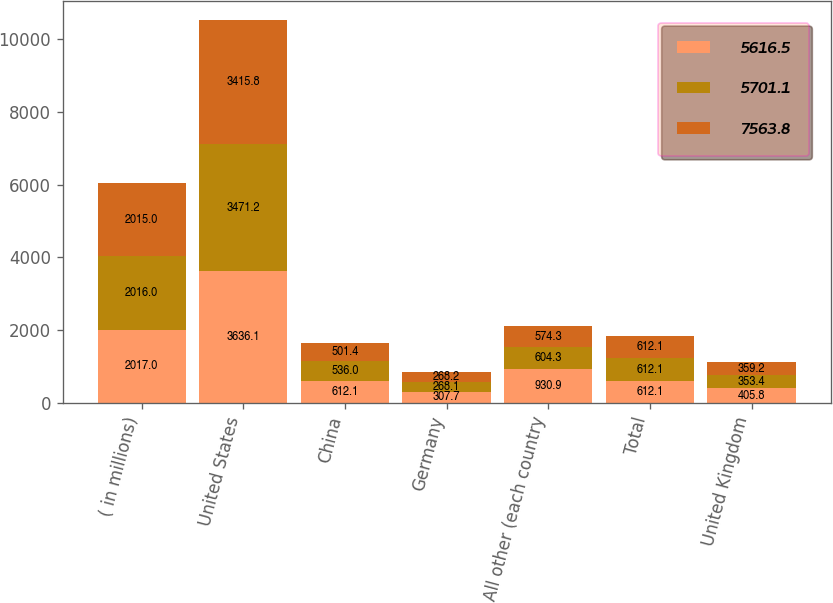Convert chart to OTSL. <chart><loc_0><loc_0><loc_500><loc_500><stacked_bar_chart><ecel><fcel>( in millions)<fcel>United States<fcel>China<fcel>Germany<fcel>All other (each country<fcel>Total<fcel>United Kingdom<nl><fcel>5616.5<fcel>2017<fcel>3636.1<fcel>612.1<fcel>307.7<fcel>930.9<fcel>612.1<fcel>405.8<nl><fcel>5701.1<fcel>2016<fcel>3471.2<fcel>536<fcel>268.1<fcel>604.3<fcel>612.1<fcel>353.4<nl><fcel>7563.8<fcel>2015<fcel>3415.8<fcel>501.4<fcel>268.2<fcel>574.3<fcel>612.1<fcel>359.2<nl></chart> 